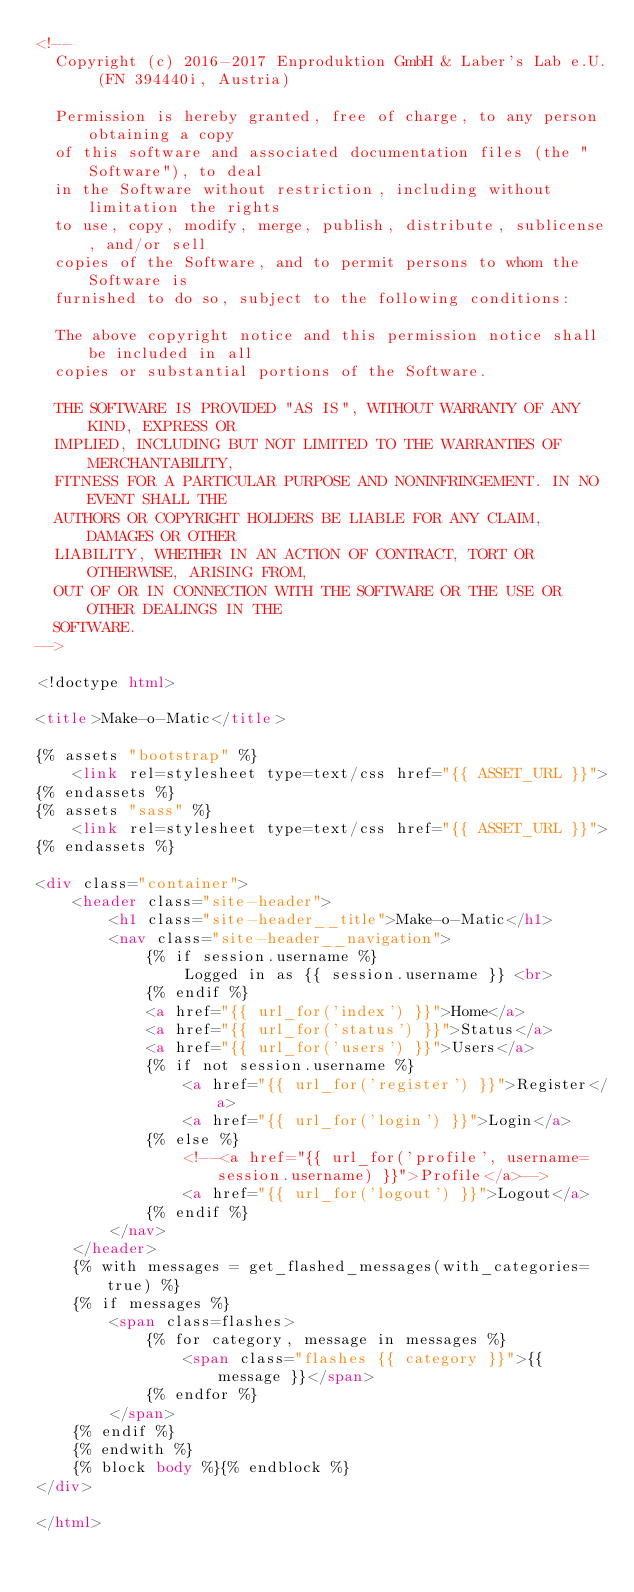<code> <loc_0><loc_0><loc_500><loc_500><_HTML_><!--
  Copyright (c) 2016-2017 Enproduktion GmbH & Laber's Lab e.U. (FN 394440i, Austria)

  Permission is hereby granted, free of charge, to any person obtaining a copy
  of this software and associated documentation files (the "Software"), to deal
  in the Software without restriction, including without limitation the rights
  to use, copy, modify, merge, publish, distribute, sublicense, and/or sell
  copies of the Software, and to permit persons to whom the Software is
  furnished to do so, subject to the following conditions:

  The above copyright notice and this permission notice shall be included in all
  copies or substantial portions of the Software.

  THE SOFTWARE IS PROVIDED "AS IS", WITHOUT WARRANTY OF ANY KIND, EXPRESS OR
  IMPLIED, INCLUDING BUT NOT LIMITED TO THE WARRANTIES OF MERCHANTABILITY,
  FITNESS FOR A PARTICULAR PURPOSE AND NONINFRINGEMENT. IN NO EVENT SHALL THE
  AUTHORS OR COPYRIGHT HOLDERS BE LIABLE FOR ANY CLAIM, DAMAGES OR OTHER
  LIABILITY, WHETHER IN AN ACTION OF CONTRACT, TORT OR OTHERWISE, ARISING FROM,
  OUT OF OR IN CONNECTION WITH THE SOFTWARE OR THE USE OR OTHER DEALINGS IN THE
  SOFTWARE.
-->

<!doctype html>

<title>Make-o-Matic</title>

{% assets "bootstrap" %}
    <link rel=stylesheet type=text/css href="{{ ASSET_URL }}">
{% endassets %}
{% assets "sass" %}
    <link rel=stylesheet type=text/css href="{{ ASSET_URL }}">
{% endassets %}

<div class="container">
    <header class="site-header">
        <h1 class="site-header__title">Make-o-Matic</h1>
        <nav class="site-header__navigation">
            {% if session.username %}
                Logged in as {{ session.username }} <br>
            {% endif %}
            <a href="{{ url_for('index') }}">Home</a>
            <a href="{{ url_for('status') }}">Status</a>
            <a href="{{ url_for('users') }}">Users</a>
            {% if not session.username %}
                <a href="{{ url_for('register') }}">Register</a>
                <a href="{{ url_for('login') }}">Login</a>
            {% else %}
                <!--<a href="{{ url_for('profile', username=session.username) }}">Profile</a>-->
                <a href="{{ url_for('logout') }}">Logout</a>
            {% endif %}
        </nav>
    </header>
    {% with messages = get_flashed_messages(with_categories=true) %}
    {% if messages %}
        <span class=flashes>
            {% for category, message in messages %}
                <span class="flashes {{ category }}">{{ message }}</span>
            {% endfor %}
        </span>
    {% endif %}
    {% endwith %}
    {% block body %}{% endblock %}
</div>

</html>
</code> 